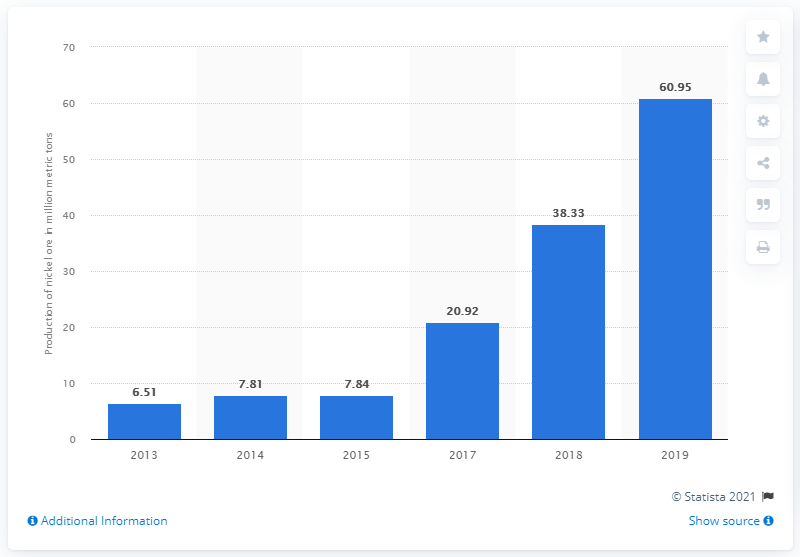Identify some key points in this picture. In 2019, a total of 60.95 metric tons of nickel ore was produced in Indonesia. In 2018, a total of 38.33 metric tons of nickel ore were produced in Indonesia. 